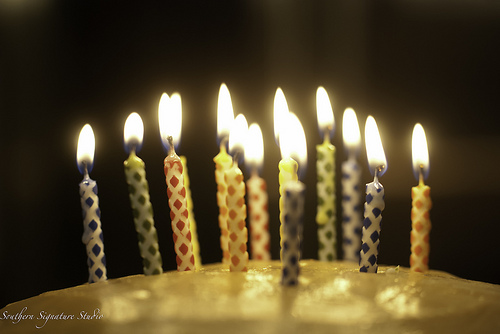<image>
Can you confirm if the diamond is on the cake? No. The diamond is not positioned on the cake. They may be near each other, but the diamond is not supported by or resting on top of the cake. 